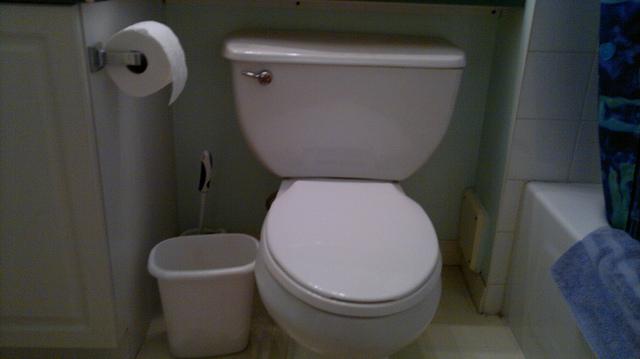Is this a conventional toilet?
Short answer required. Yes. Is the trash can empty?
Quick response, please. Yes. What's next to the toilet?
Keep it brief. Trash can. How many toilets are there?
Keep it brief. 1. How many rolls of toilet paper are here?
Answer briefly. 1. How many rolls of toilet paper are shown?
Quick response, please. 1. Is the toilet paper full?
Concise answer only. Yes. Is the toilet paper over or under?
Give a very brief answer. Over. How many extra rolls of toilet paper are being stored here?
Quick response, please. 0. How would you flush this toilet?
Short answer required. Handle. Where is the button to flush the toilet?
Give a very brief answer. Top left. How many rolls of toilet paper in this scene?
Short answer required. 1. What is the purpose of the object behind the toilet?
Keep it brief. Cleaning. Is there a towel on the bathtub?
Be succinct. Yes. What type of cat is this?
Give a very brief answer. None. 